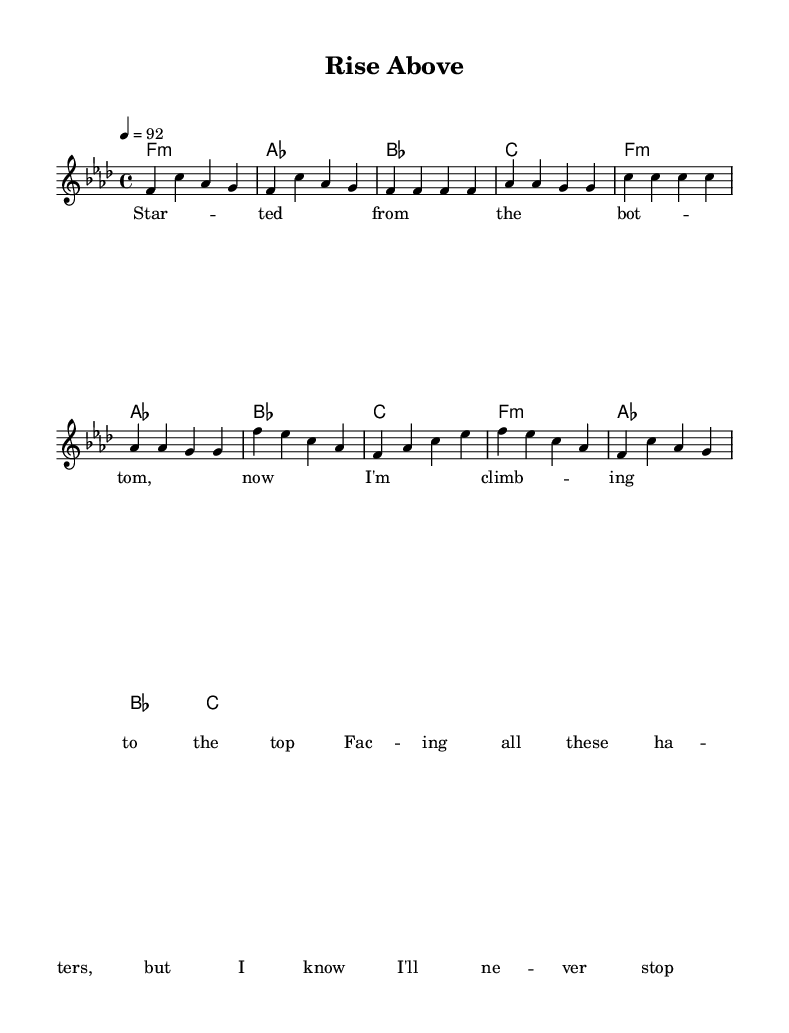What is the key signature of this music? The key signature is indicated by the sharp or flat symbols at the beginning of the staff. In this case, it shows an F minor key signature, which has four flats (B, E, A, and D).
Answer: F minor What is the time signature of this piece? The time signature is represented by the numbers at the beginning of the score. Here, it shows 4 over 4, meaning there are four beats in each measure and the quarter note gets one beat.
Answer: 4/4 What is the tempo marking for this track? The tempo marking is defined at the start of the score and indicates how fast the piece should be played. In this music, the tempo is set to 92 beats per minute.
Answer: 92 How many measures are in the verse? To determine this, count the bars (vertical lines) that separate each measure in the verse section. There are four bars in the verse part shown in the sheet.
Answer: 4 What is the primary lyrical theme of this piece? The title "Rise Above" and the lyrics suggest that the theme focuses on overcoming challenges and obstacles. It emphasizes resilience and determination against adversity in the music industry.
Answer: Overcoming obstacles Which section contains the lyrics 'Rise above'? By checking the sections within the sheet music, 'Rise above' appears in the chorus section of the song. This chorus typically follows the verse and reinforces the main message.
Answer: Chorus What type of musical style does this piece represent? This piece is characterized as a motivation-driven hip-hop style, particularly focusing on rap elements. The rhythm, lyrical structure, and message align with hip-hop traditions.
Answer: Hip-hop 